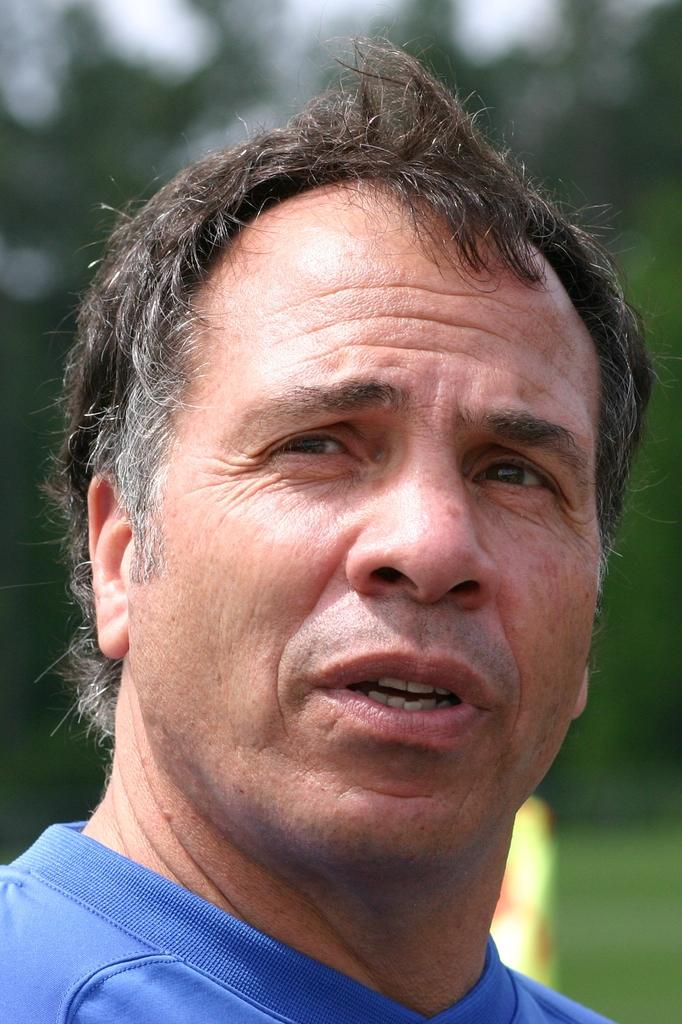Who or what is the main subject of the image? There is a person in the image. Can you describe the background of the image? The background of the image is blurry. How many folds are visible in the tin cannon in the image? There is no tin cannon present in the image, so the number of folds cannot be determined. 